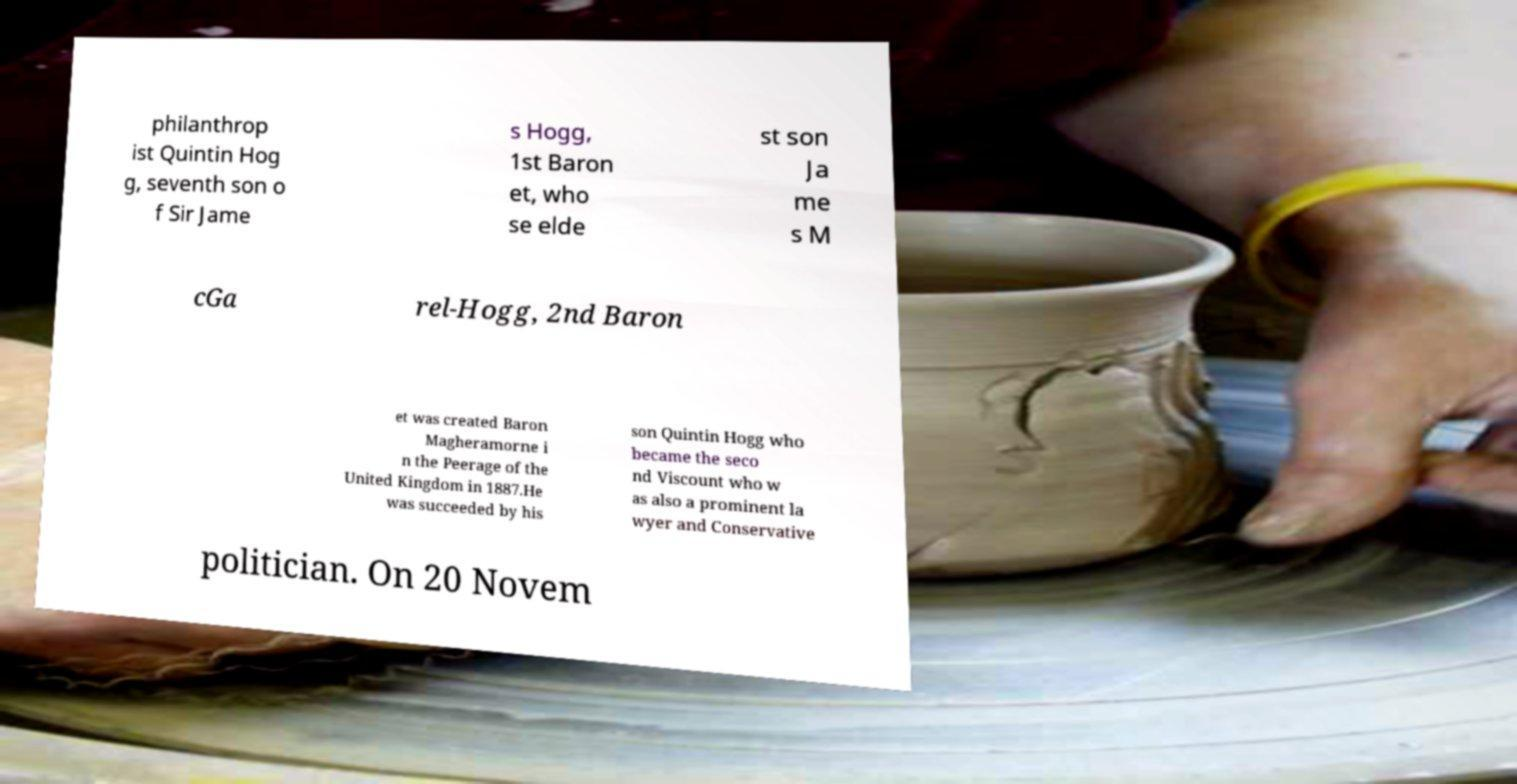Could you extract and type out the text from this image? philanthrop ist Quintin Hog g, seventh son o f Sir Jame s Hogg, 1st Baron et, who se elde st son Ja me s M cGa rel-Hogg, 2nd Baron et was created Baron Magheramorne i n the Peerage of the United Kingdom in 1887.He was succeeded by his son Quintin Hogg who became the seco nd Viscount who w as also a prominent la wyer and Conservative politician. On 20 Novem 